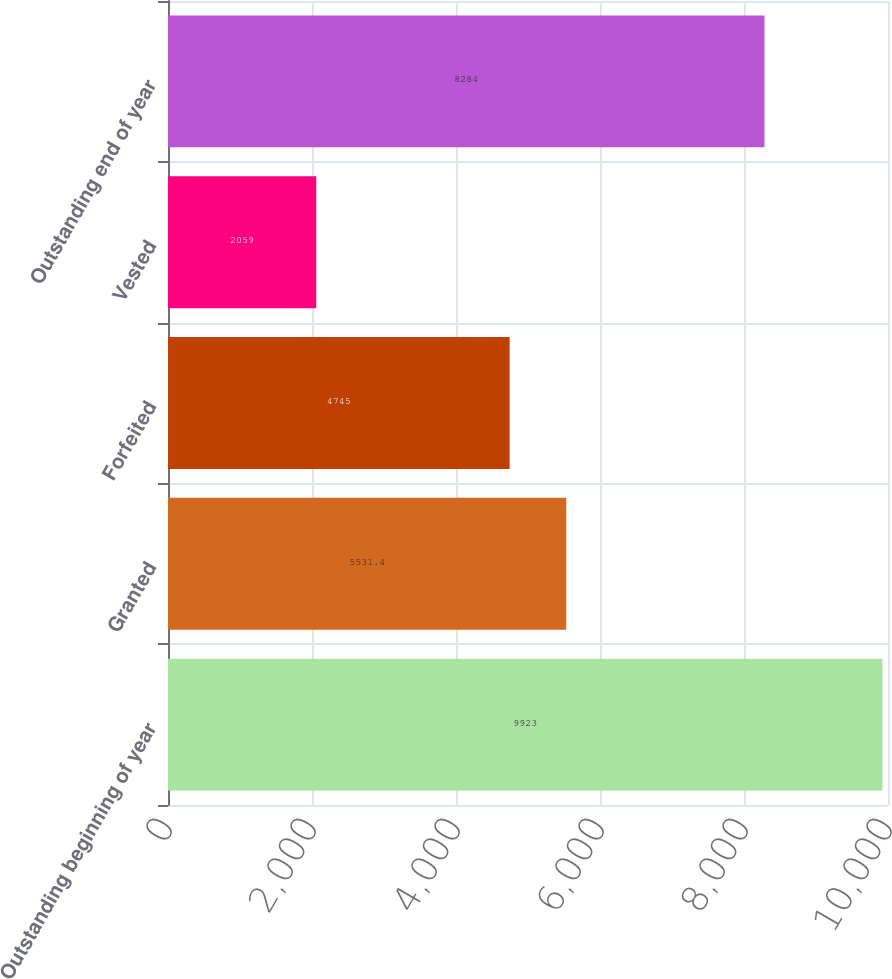<chart> <loc_0><loc_0><loc_500><loc_500><bar_chart><fcel>Outstanding beginning of year<fcel>Granted<fcel>Forfeited<fcel>Vested<fcel>Outstanding end of year<nl><fcel>9923<fcel>5531.4<fcel>4745<fcel>2059<fcel>8284<nl></chart> 